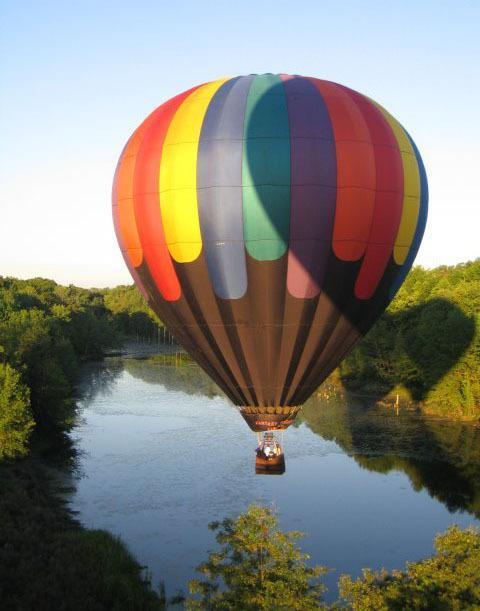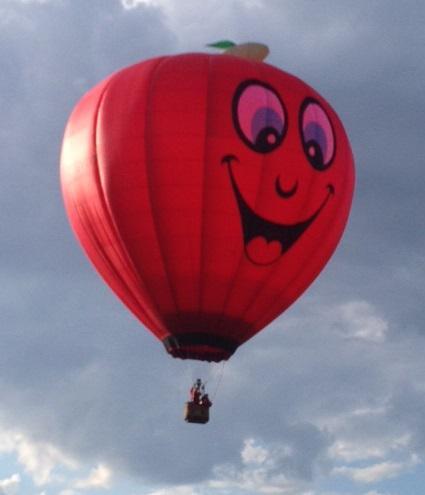The first image is the image on the left, the second image is the image on the right. Analyze the images presented: Is the assertion "In total, two balloons are in the air rather than on the ground." valid? Answer yes or no. Yes. The first image is the image on the left, the second image is the image on the right. For the images shown, is this caption "Two hot air balloons with baskets are floating above ground." true? Answer yes or no. Yes. 